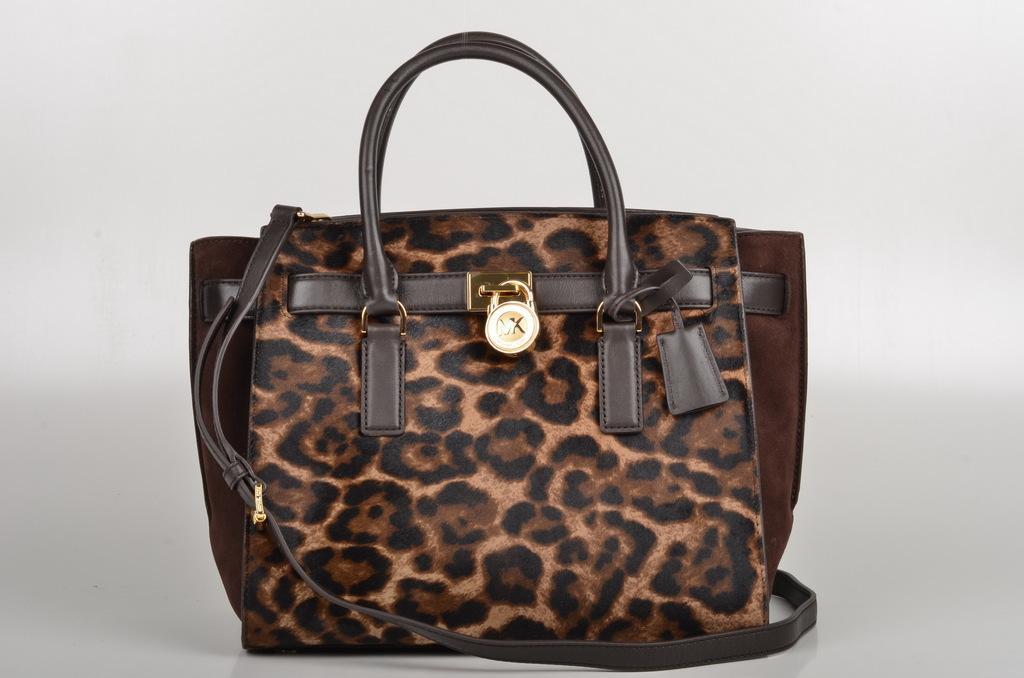Describe this image in one or two sentences. Here in the center we can see one bag which is in brown color. 